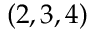Convert formula to latex. <formula><loc_0><loc_0><loc_500><loc_500>( 2 , 3 , 4 )</formula> 